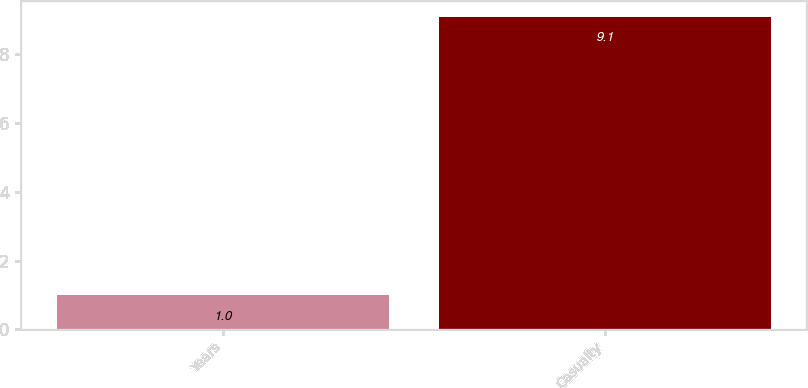Convert chart to OTSL. <chart><loc_0><loc_0><loc_500><loc_500><bar_chart><fcel>Years<fcel>Casualty<nl><fcel>1<fcel>9.1<nl></chart> 